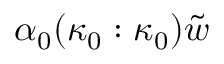<formula> <loc_0><loc_0><loc_500><loc_500>\alpha _ { 0 } ( \kappa _ { 0 } \colon \kappa _ { 0 } ) \tilde { w }</formula> 